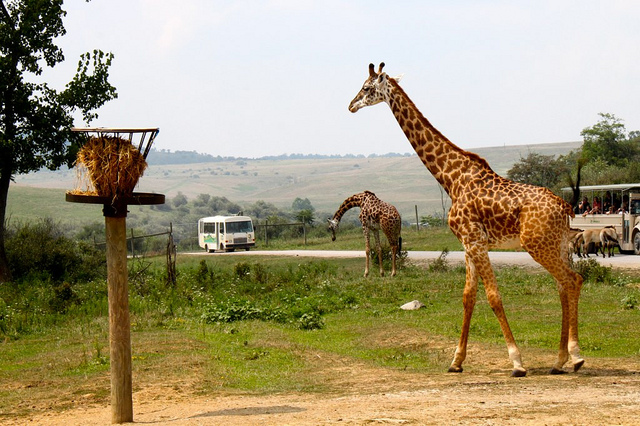What are the people on the vehicle to the right involved in? A. hitch hiking B. school ride C. selling D. safari Answer with the option's letter from the given choices directly. The correct answer is D, safari. The image clearly depicts a safari scene where individuals are likely observing wildlife from a specialized vehicle, typical of safari tours aimed at providing safe and close encounters with wildlife, such as the giraffes seen in their natural habitat. 